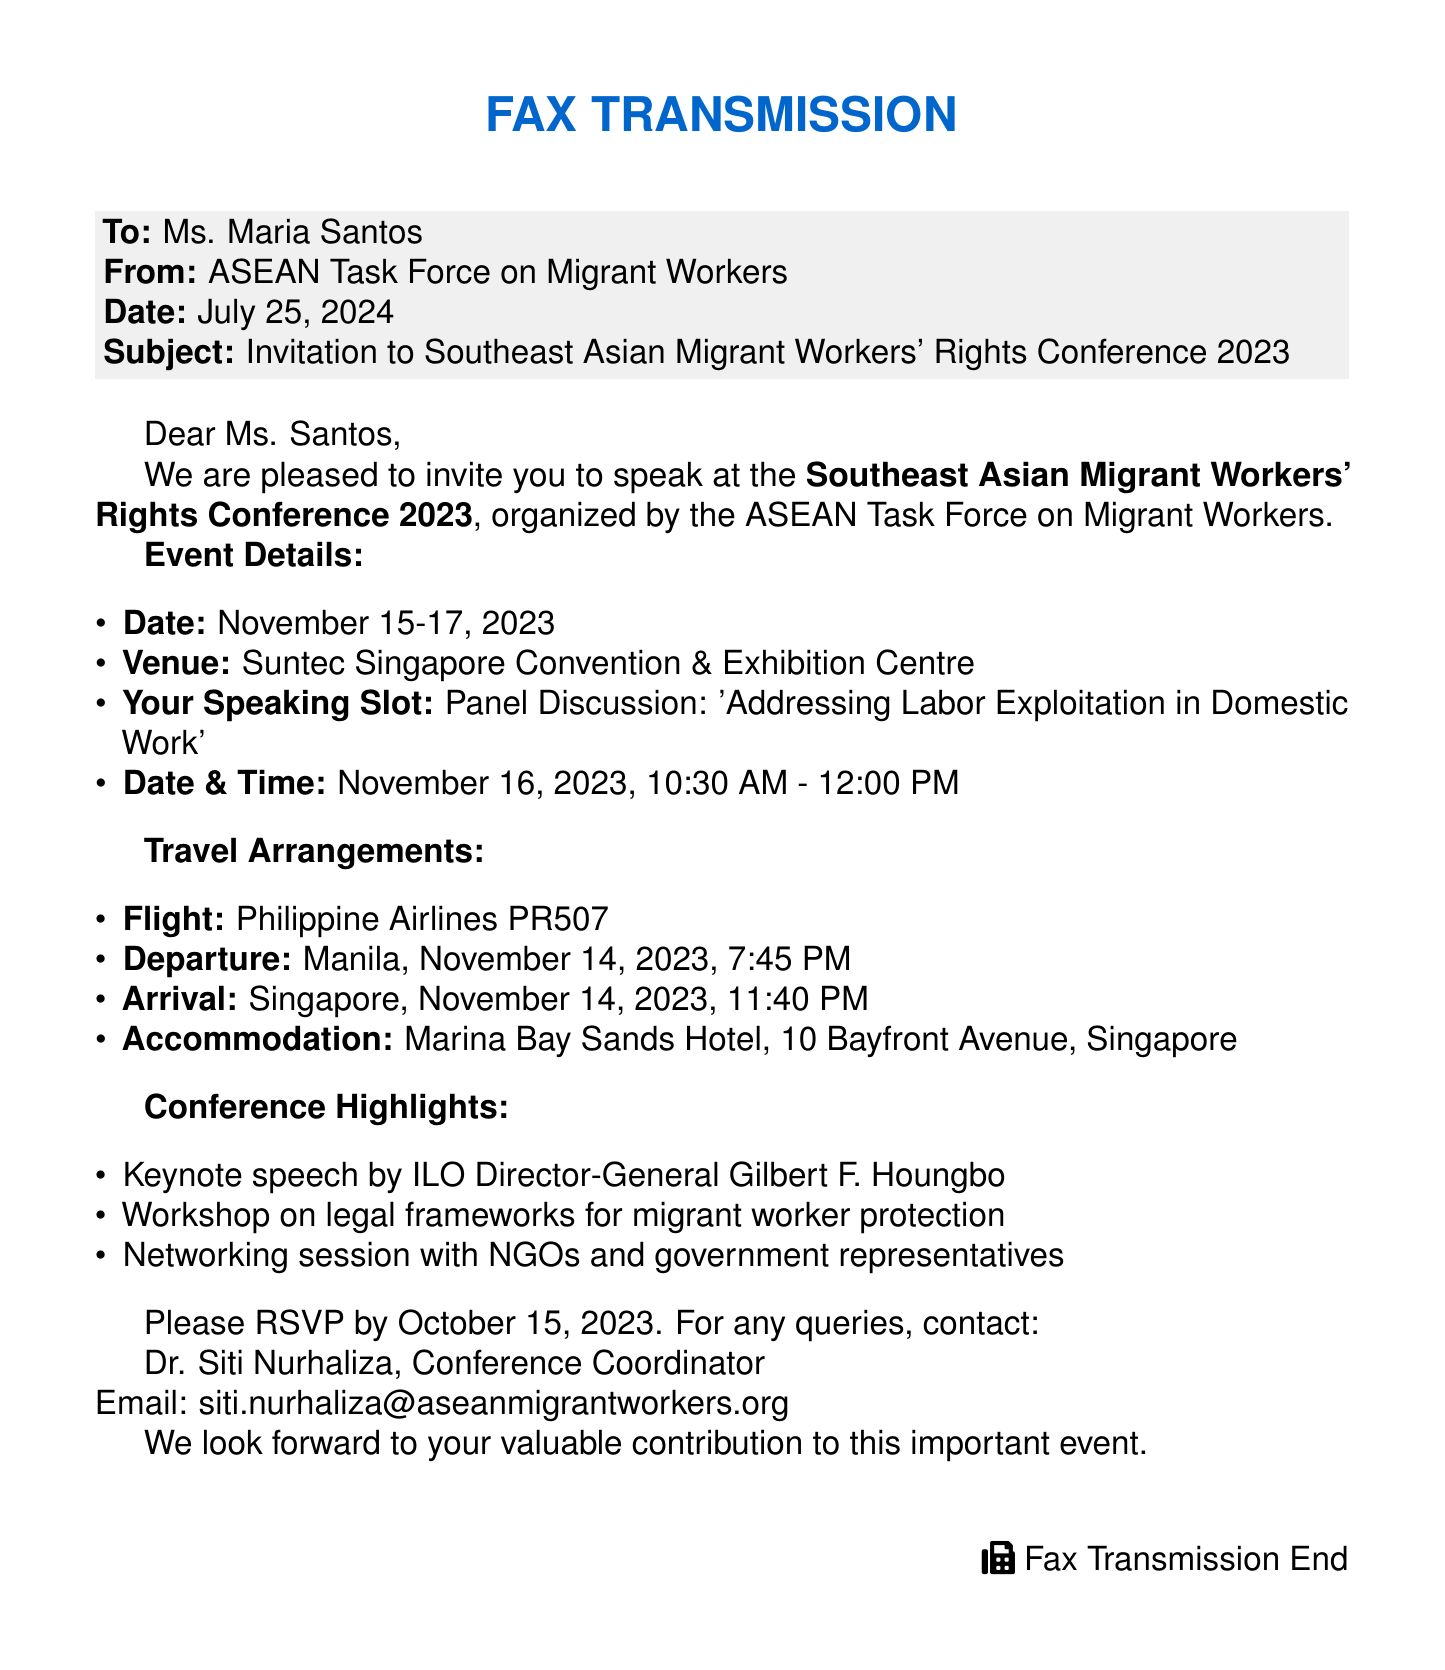What is the date of the conference? The document states that the conference will take place on November 15-17, 2023.
Answer: November 15-17, 2023 Who is invited to speak at the conference? The fax invites Ms. Maria Santos to speak at the conference.
Answer: Ms. Maria Santos What is the topic of the panel discussion where Ms. Santos will speak? The document specifies that the topic is 'Addressing Labor Exploitation in Domestic Work.'
Answer: Addressing Labor Exploitation in Domestic Work What time is Ms. Santos's speaking slot? The speaking slot is scheduled for November 16, 2023, from 10:30 AM to 12:00 PM.
Answer: 10:30 AM - 12:00 PM What is the name of the hotel where accommodation is provided? The fax mentions that accommodation will be at Marina Bay Sands Hotel.
Answer: Marina Bay Sands Hotel When is the RSVP deadline for the invitation? The document indicates that the RSVP deadline is October 15, 2023.
Answer: October 15, 2023 What is the flight number for Ms. Santos's travel? The document provides the flight number as Philippine Airlines PR507.
Answer: Philippine Airlines PR507 Who is the conference coordinator? The fax states that the conference coordinator is Dr. Siti Nurhaliza.
Answer: Dr. Siti Nurhaliza What is the venue for the conference? The document identifies the venue as Suntec Singapore Convention & Exhibition Centre.
Answer: Suntec Singapore Convention & Exhibition Centre 